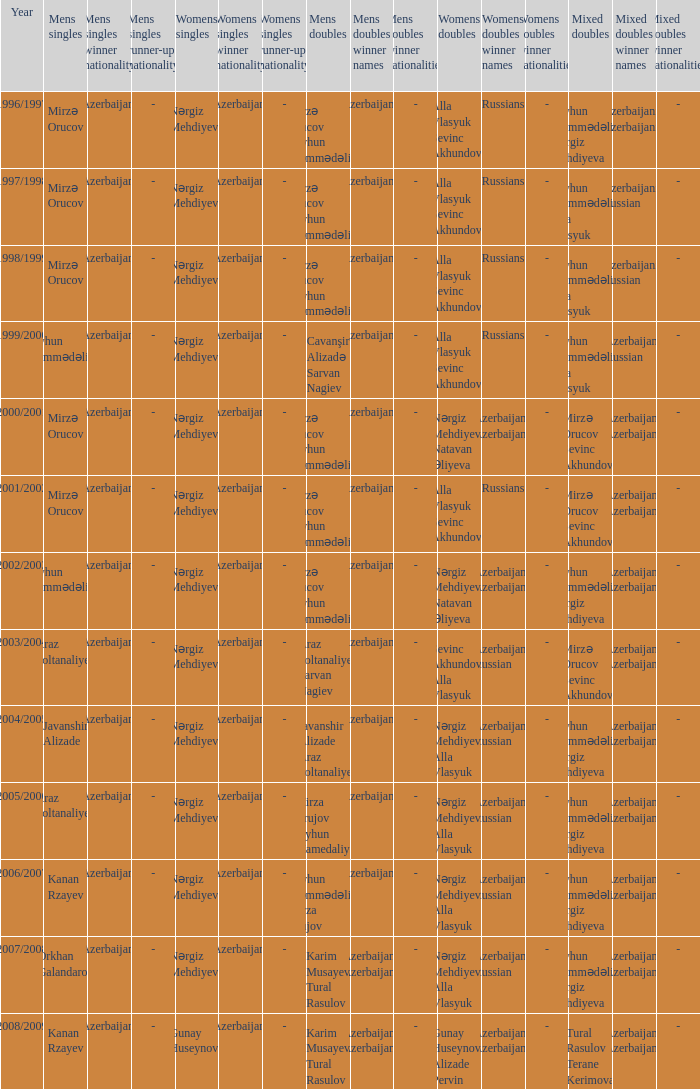Who were all womens doubles for the year 2000/2001? Nərgiz Mehdiyeva Natavan Əliyeva. 